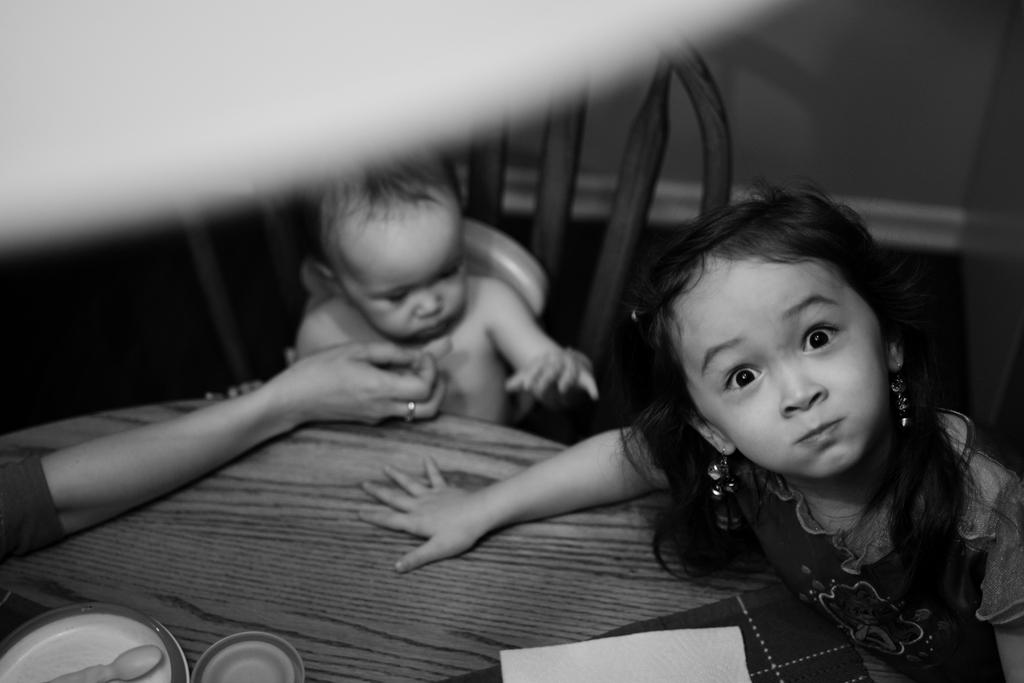What is the child doing in the image? The child is sitting on a chair in the image. Can you describe the gender of the child? There is a girl in the image. What items can be seen on the table in the image? There is a cloth, a plate, tissue paper, and a person's hand visible on the table in the image. What is the background of the image? There is a wall in the background of the image. How many objects are present in the image? There are some objects in the image, but the exact number is not specified. What type of test is the child taking in the image? There is no test present in the image; the child is simply sitting on a chair. What is the child using to paste the paper in the image? There is no paper or paste present in the image; the child is just sitting on a chair. 